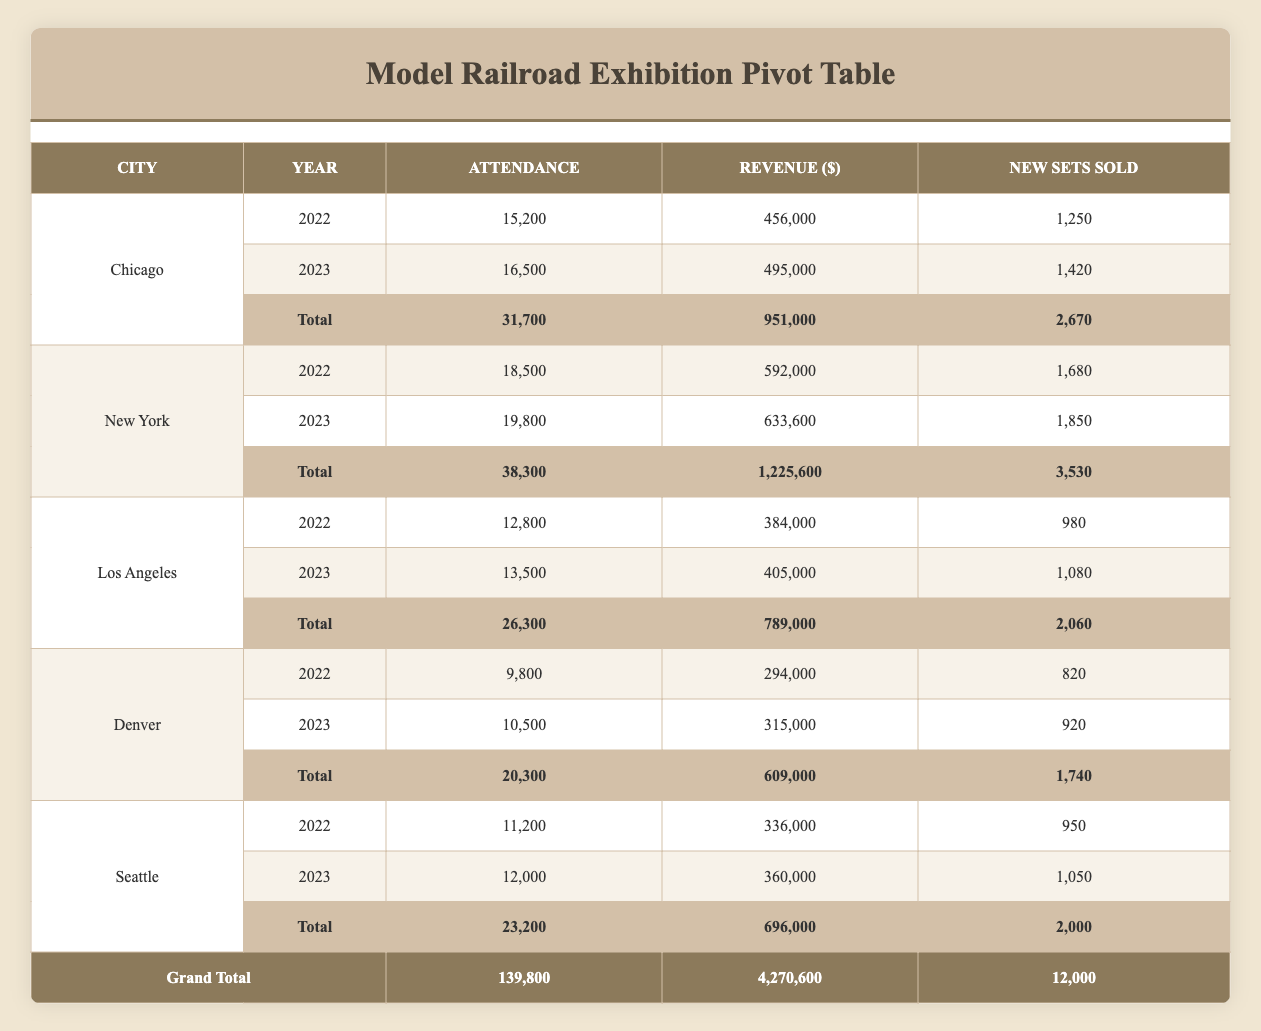What is the total attendance for the Midwest Model Railroad Show in 2022 and 2023? In the table, the attendance for the Midwest Model Railroad Show in 2022 is 15,200. In 2023, the attendance is 16,500. Adding these two figures gives a total of (15,200 + 16,500) = 31,700.
Answer: 31,700 What city had the highest revenue in 2022? Looking at the revenue figures for each city in 2022, Chicago had revenue of 456,000, New York had 592,000, Los Angeles had 384,000, Denver had 294,000, and Seattle had 336,000. The highest figure is 592,000 for New York.
Answer: New York What is the total amount of revenue generated across all events in 2023? To find the total revenue for 2023, sum the revenue figures for each event: Chicago (495,000) + New York (633,600) + Los Angeles (405,000) + Denver (315,000) + Seattle (360,000), which equals 495,000 + 633,600 + 405,000 + 315,000 + 360,000 = 2,208,600.
Answer: 2,208,600 Did attendance at the Rocky Mountain Train Show increase from 2022 to 2023? In 2022, the attendance was 9,800, and in 2023 it was 10,500. Since 10,500 is greater than 9,800, attendance did increase.
Answer: Yes Which city had the lowest total new sets sold in 2022 and 2023 combined? To find the city with the lowest new sets sold, add the new sets sold for each city. Chicago (2,670), New York (3,530), Los Angeles (2,060), Denver (1,740), Seattle (2,000). The lowest total is 1,740 for Denver.
Answer: Denver What is the average attendance for the Empire State Train Show events? The attendance for the Empire State Train Show in 2022 is 18,500 and in 2023 is 19,800. To find the average, add these together (18,500 + 19,800 = 38,300) and divide by the number of events (2). The average attendance is 38,300 / 2 = 19,150.
Answer: 19,150 Is the total new sets sold in 2023 greater than the total new sets sold in 2022? The total new sets sold in 2023 is 12,000 and in 2022 is 12,000 (2,670 + 3,530 + 2,060 + 1,740 + 2,000 = 12,000). Since 12,000 is equal, it is not greater.
Answer: No Which year had a greater total attendance across all cities? The total attendance for each year is calculated as follows: 2022 (15,200 + 18,500 + 12,800 + 9,800 + 11,200 = 67,500) and 2023 (16,500 + 19,800 + 13,500 + 10,500 + 12,000 = 72,300). Since 72,300 in 2023 is greater than 67,500 in 2022, 2023 had greater attendance.
Answer: 2023 